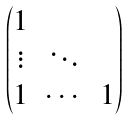Convert formula to latex. <formula><loc_0><loc_0><loc_500><loc_500>\begin{pmatrix} 1 & & \\ \vdots & \ddots & \\ 1 & \cdots & 1 \end{pmatrix}</formula> 